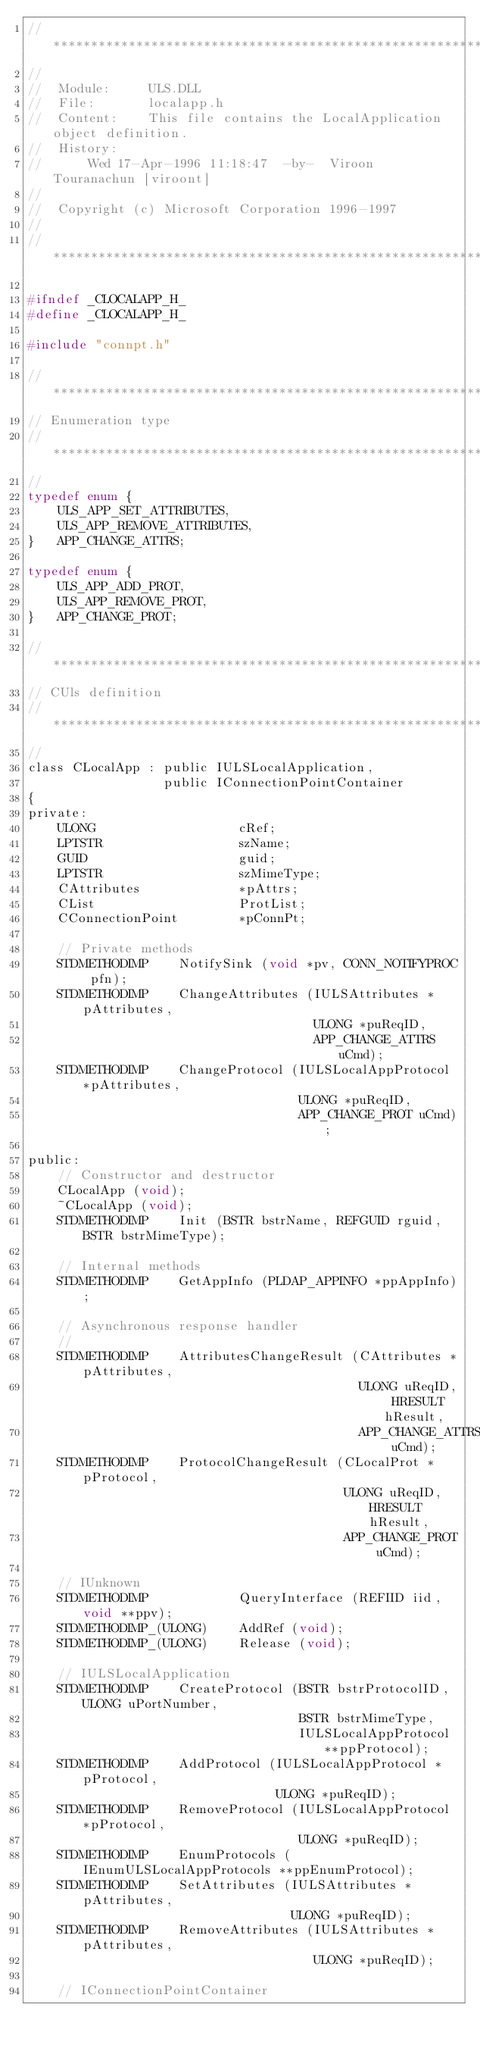<code> <loc_0><loc_0><loc_500><loc_500><_C_>//****************************************************************************
//
//  Module:     ULS.DLL
//  File:       localapp.h
//  Content:    This file contains the LocalApplication object definition.
//  History:
//      Wed 17-Apr-1996 11:18:47  -by-  Viroon  Touranachun [viroont]
//
//  Copyright (c) Microsoft Corporation 1996-1997
//
//****************************************************************************

#ifndef _CLOCALAPP_H_
#define _CLOCALAPP_H_

#include "connpt.h"

//****************************************************************************
// Enumeration type
//****************************************************************************
//
typedef enum {
    ULS_APP_SET_ATTRIBUTES,
    ULS_APP_REMOVE_ATTRIBUTES,
}   APP_CHANGE_ATTRS;

typedef enum {
    ULS_APP_ADD_PROT,
    ULS_APP_REMOVE_PROT,
}   APP_CHANGE_PROT;

//****************************************************************************
// CUls definition
//****************************************************************************
//
class CLocalApp : public IULSLocalApplication,
                  public IConnectionPointContainer 
{
private:
    ULONG                   cRef;
    LPTSTR                  szName;
    GUID                    guid;
    LPTSTR                  szMimeType;
    CAttributes             *pAttrs;
    CList                   ProtList;
    CConnectionPoint        *pConnPt;

    // Private methods
    STDMETHODIMP    NotifySink (void *pv, CONN_NOTIFYPROC pfn);
    STDMETHODIMP    ChangeAttributes (IULSAttributes *pAttributes,
                                      ULONG *puReqID,
                                      APP_CHANGE_ATTRS uCmd);
    STDMETHODIMP    ChangeProtocol (IULSLocalAppProtocol *pAttributes,
                                    ULONG *puReqID,
                                    APP_CHANGE_PROT uCmd);

public:
    // Constructor and destructor
    CLocalApp (void);
    ~CLocalApp (void);
    STDMETHODIMP    Init (BSTR bstrName, REFGUID rguid, BSTR bstrMimeType);

    // Internal methods
    STDMETHODIMP    GetAppInfo (PLDAP_APPINFO *ppAppInfo);

    // Asynchronous response handler
    //
    STDMETHODIMP    AttributesChangeResult (CAttributes *pAttributes,
                                            ULONG uReqID, HRESULT hResult,
                                            APP_CHANGE_ATTRS uCmd);
    STDMETHODIMP    ProtocolChangeResult (CLocalProt *pProtocol,
                                          ULONG uReqID, HRESULT hResult,
                                          APP_CHANGE_PROT uCmd);

    // IUnknown
    STDMETHODIMP            QueryInterface (REFIID iid, void **ppv);
    STDMETHODIMP_(ULONG)    AddRef (void);
    STDMETHODIMP_(ULONG)    Release (void);

    // IULSLocalApplication
    STDMETHODIMP    CreateProtocol (BSTR bstrProtocolID, ULONG uPortNumber,
                                    BSTR bstrMimeType,
                                    IULSLocalAppProtocol **ppProtocol);
    STDMETHODIMP    AddProtocol (IULSLocalAppProtocol *pProtocol,
                                 ULONG *puReqID);
    STDMETHODIMP    RemoveProtocol (IULSLocalAppProtocol *pProtocol,
                                    ULONG *puReqID);
    STDMETHODIMP    EnumProtocols (IEnumULSLocalAppProtocols **ppEnumProtocol);
    STDMETHODIMP    SetAttributes (IULSAttributes *pAttributes,
                                   ULONG *puReqID);
    STDMETHODIMP    RemoveAttributes (IULSAttributes *pAttributes,
                                      ULONG *puReqID);

    // IConnectionPointContainer</code> 